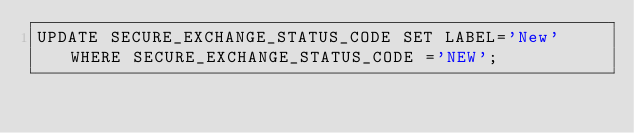Convert code to text. <code><loc_0><loc_0><loc_500><loc_500><_SQL_>UPDATE SECURE_EXCHANGE_STATUS_CODE SET LABEL='New' WHERE SECURE_EXCHANGE_STATUS_CODE ='NEW';</code> 